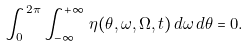<formula> <loc_0><loc_0><loc_500><loc_500>\int _ { 0 } ^ { 2 \pi } \int _ { - \infty } ^ { + \infty } \, \eta ( \theta , \omega , \Omega , t ) \, d \omega \, d \theta = 0 .</formula> 